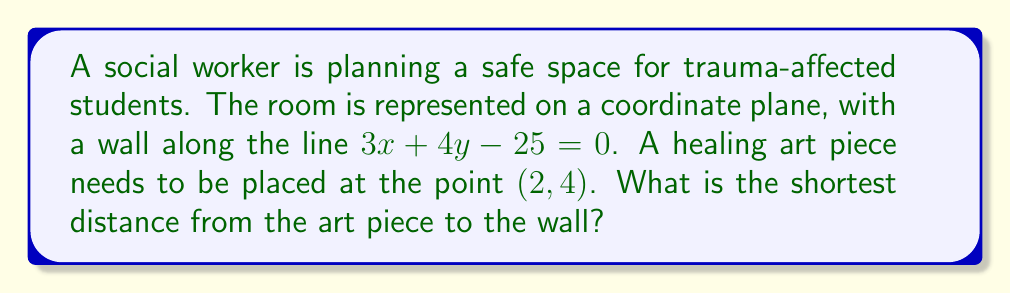Show me your answer to this math problem. To find the shortest distance from a point to a line, we'll use the formula:

$$d = \frac{|ax_0 + by_0 + c|}{\sqrt{a^2 + b^2}}$$

Where $(x_0, y_0)$ is the point, and the line is in the form $ax + by + c = 0$.

Step 1: Identify the components of the formula:
* $a = 3$, $b = 4$, $c = -25$ (from the line equation $3x + 4y - 25 = 0$)
* $(x_0, y_0) = (2, 4)$ (the point where the art piece is placed)

Step 2: Substitute these values into the formula:

$$d = \frac{|3(2) + 4(4) + (-25)|}{\sqrt{3^2 + 4^2}}$$

Step 3: Simplify the numerator:
$$d = \frac{|6 + 16 - 25|}{\sqrt{9 + 16}}$$
$$d = \frac{|-3|}{\sqrt{25}}$$

Step 4: Simplify further:
$$d = \frac{3}{5}$$

Therefore, the shortest distance from the art piece to the wall is $\frac{3}{5}$ units.
Answer: $\frac{3}{5}$ units 